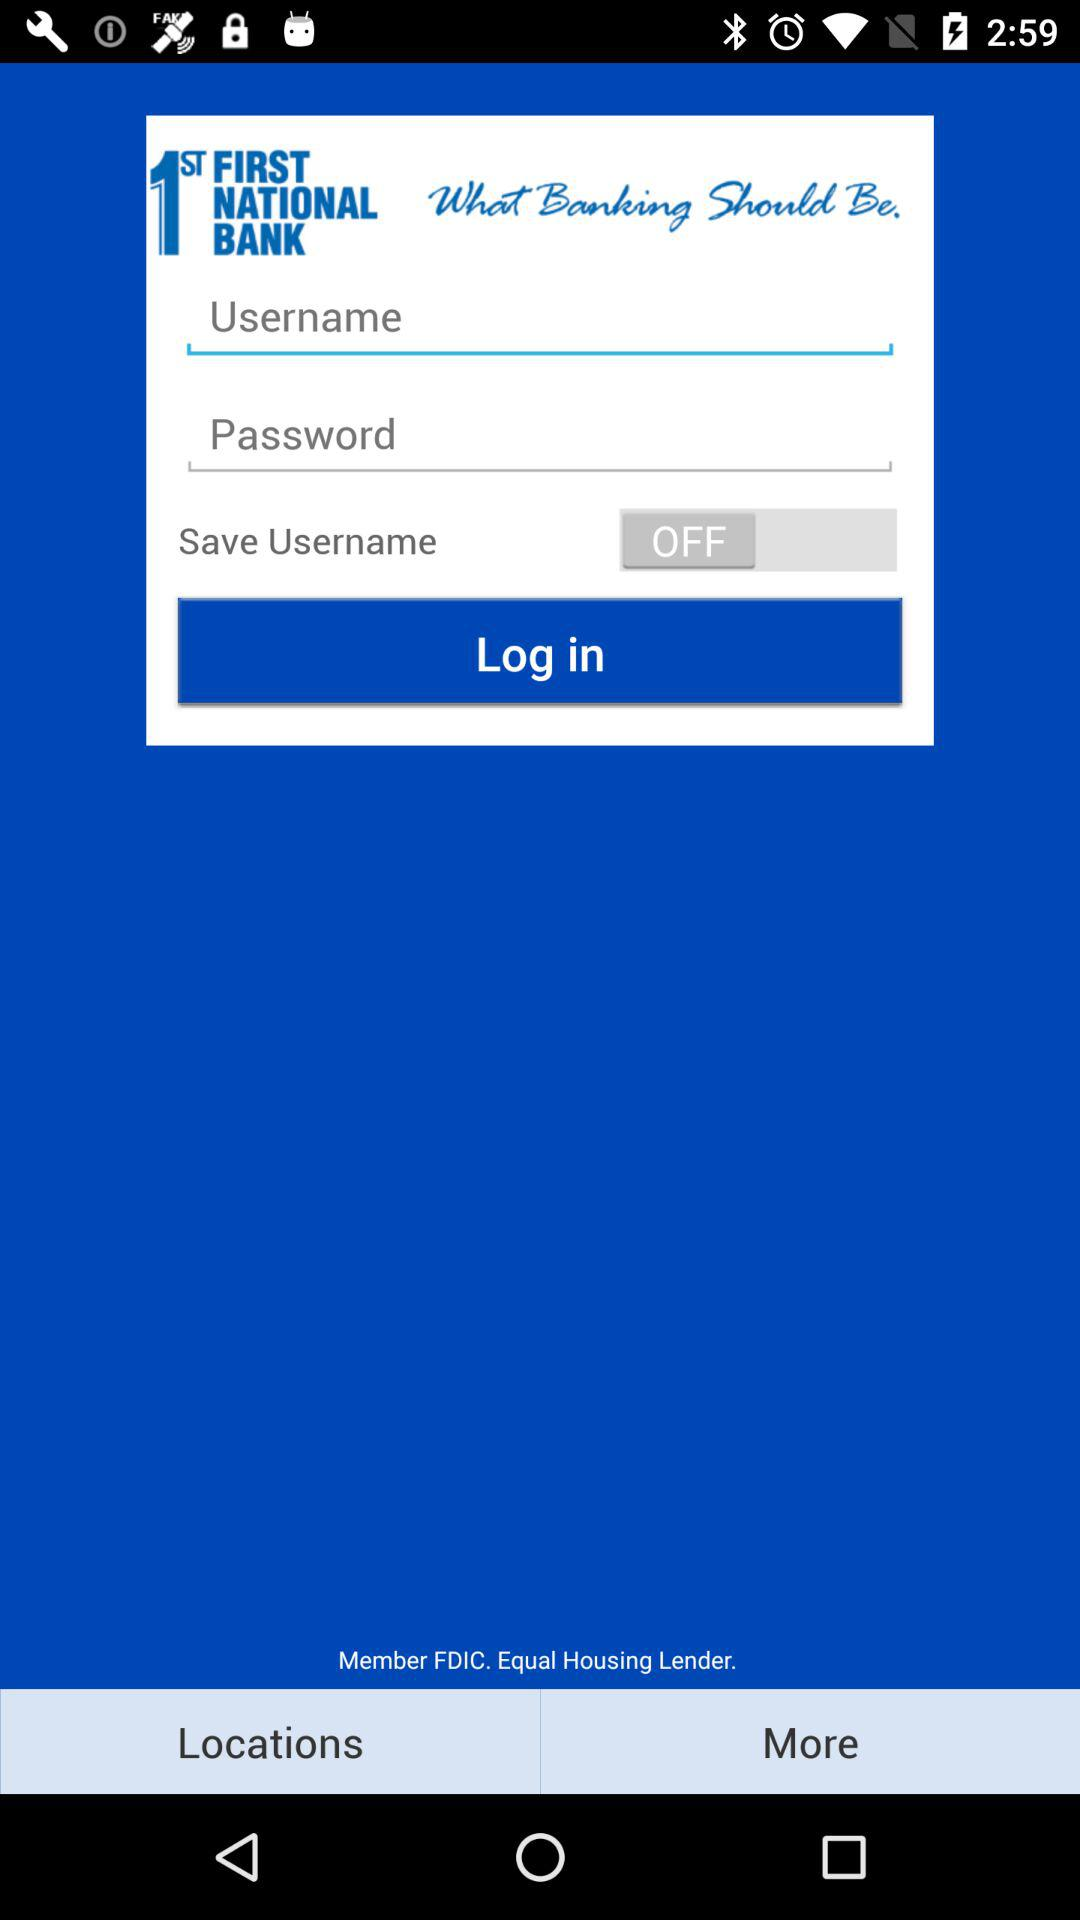How many fields are required to log in?
Answer the question using a single word or phrase. 2 